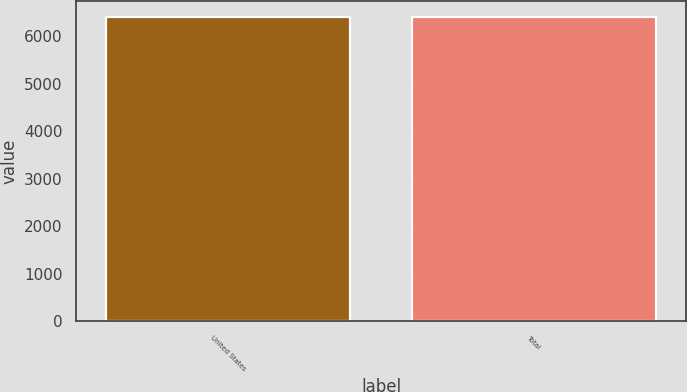Convert chart. <chart><loc_0><loc_0><loc_500><loc_500><bar_chart><fcel>United States<fcel>Total<nl><fcel>6408<fcel>6408.1<nl></chart> 